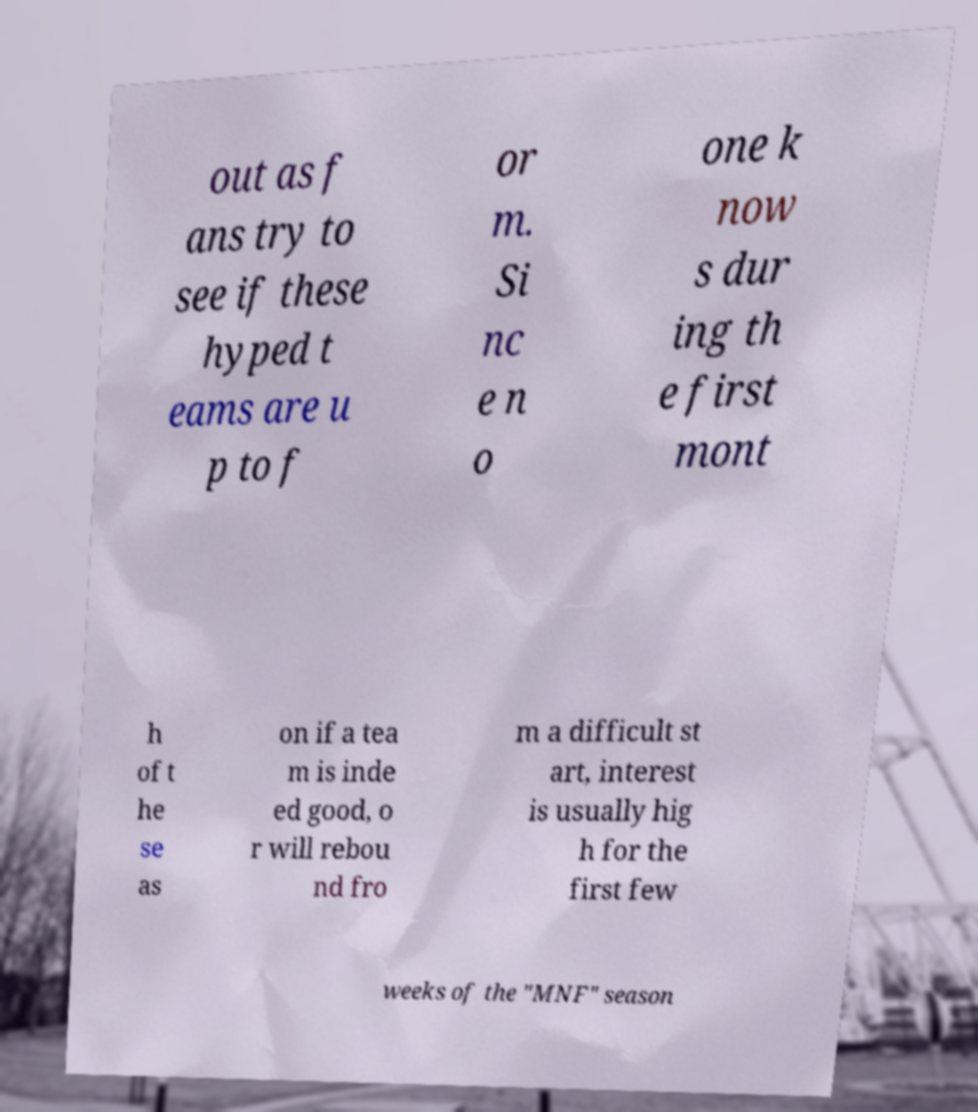Please identify and transcribe the text found in this image. out as f ans try to see if these hyped t eams are u p to f or m. Si nc e n o one k now s dur ing th e first mont h of t he se as on if a tea m is inde ed good, o r will rebou nd fro m a difficult st art, interest is usually hig h for the first few weeks of the "MNF" season 